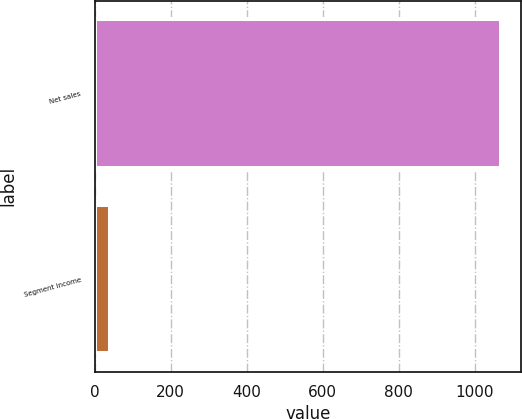Convert chart. <chart><loc_0><loc_0><loc_500><loc_500><bar_chart><fcel>Net sales<fcel>Segment income<nl><fcel>1069.1<fcel>40<nl></chart> 